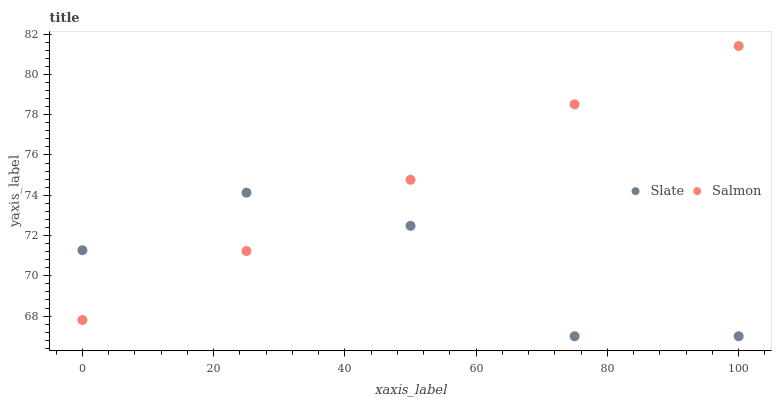Does Slate have the minimum area under the curve?
Answer yes or no. Yes. Does Salmon have the maximum area under the curve?
Answer yes or no. Yes. Does Salmon have the minimum area under the curve?
Answer yes or no. No. Is Salmon the smoothest?
Answer yes or no. Yes. Is Slate the roughest?
Answer yes or no. Yes. Is Salmon the roughest?
Answer yes or no. No. Does Slate have the lowest value?
Answer yes or no. Yes. Does Salmon have the lowest value?
Answer yes or no. No. Does Salmon have the highest value?
Answer yes or no. Yes. Does Slate intersect Salmon?
Answer yes or no. Yes. Is Slate less than Salmon?
Answer yes or no. No. Is Slate greater than Salmon?
Answer yes or no. No. 